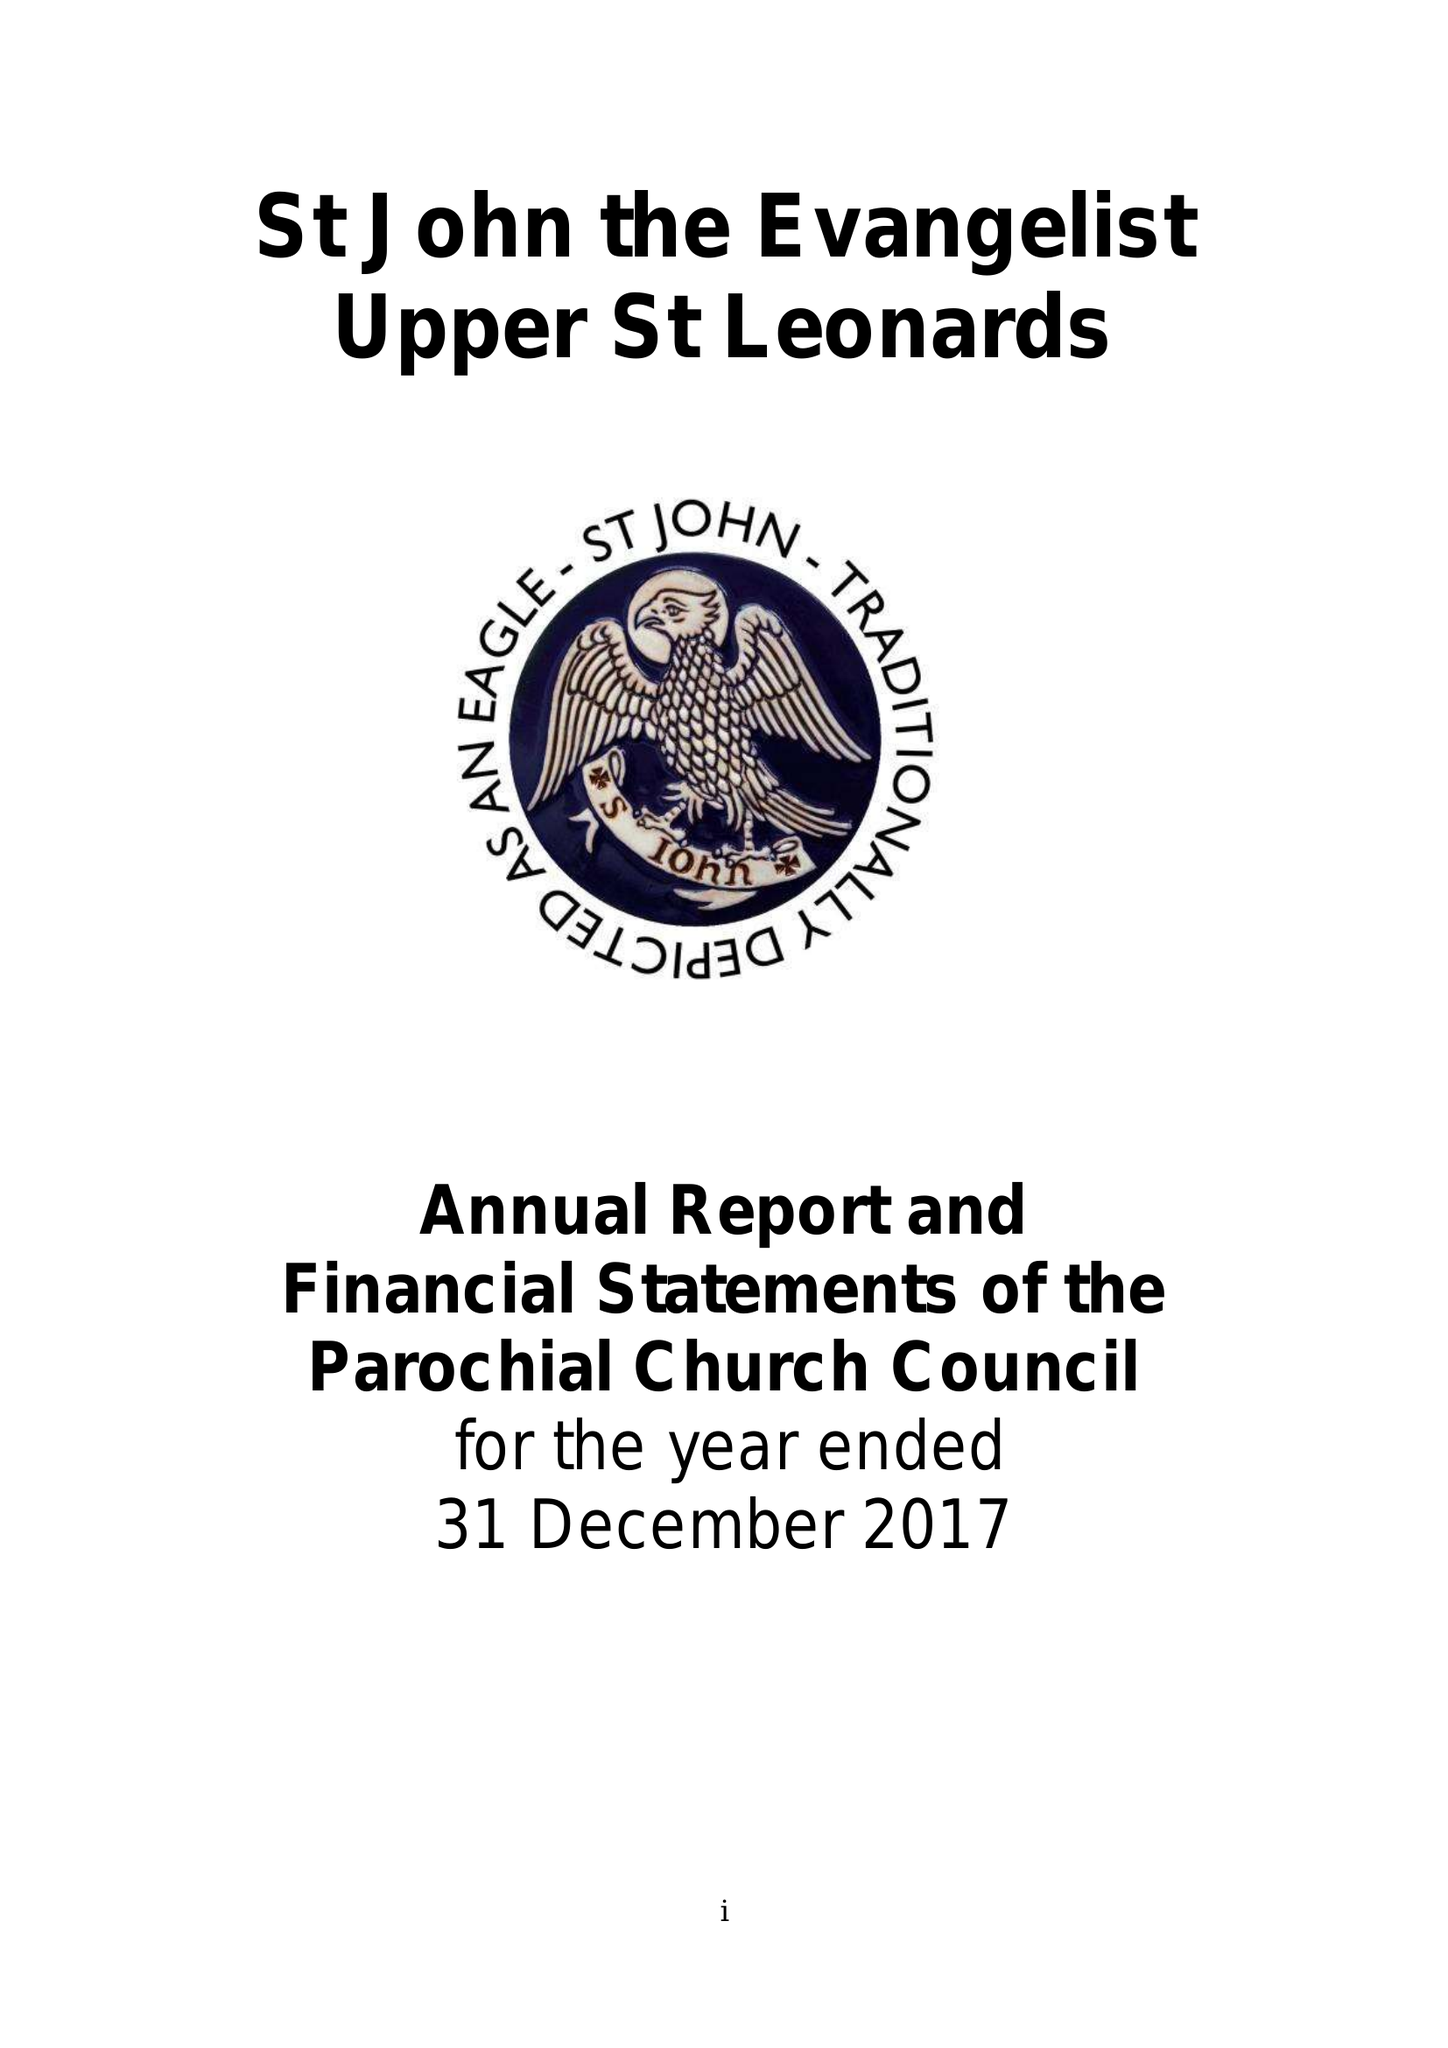What is the value for the address__postcode?
Answer the question using a single word or phrase. TN38 0LF 